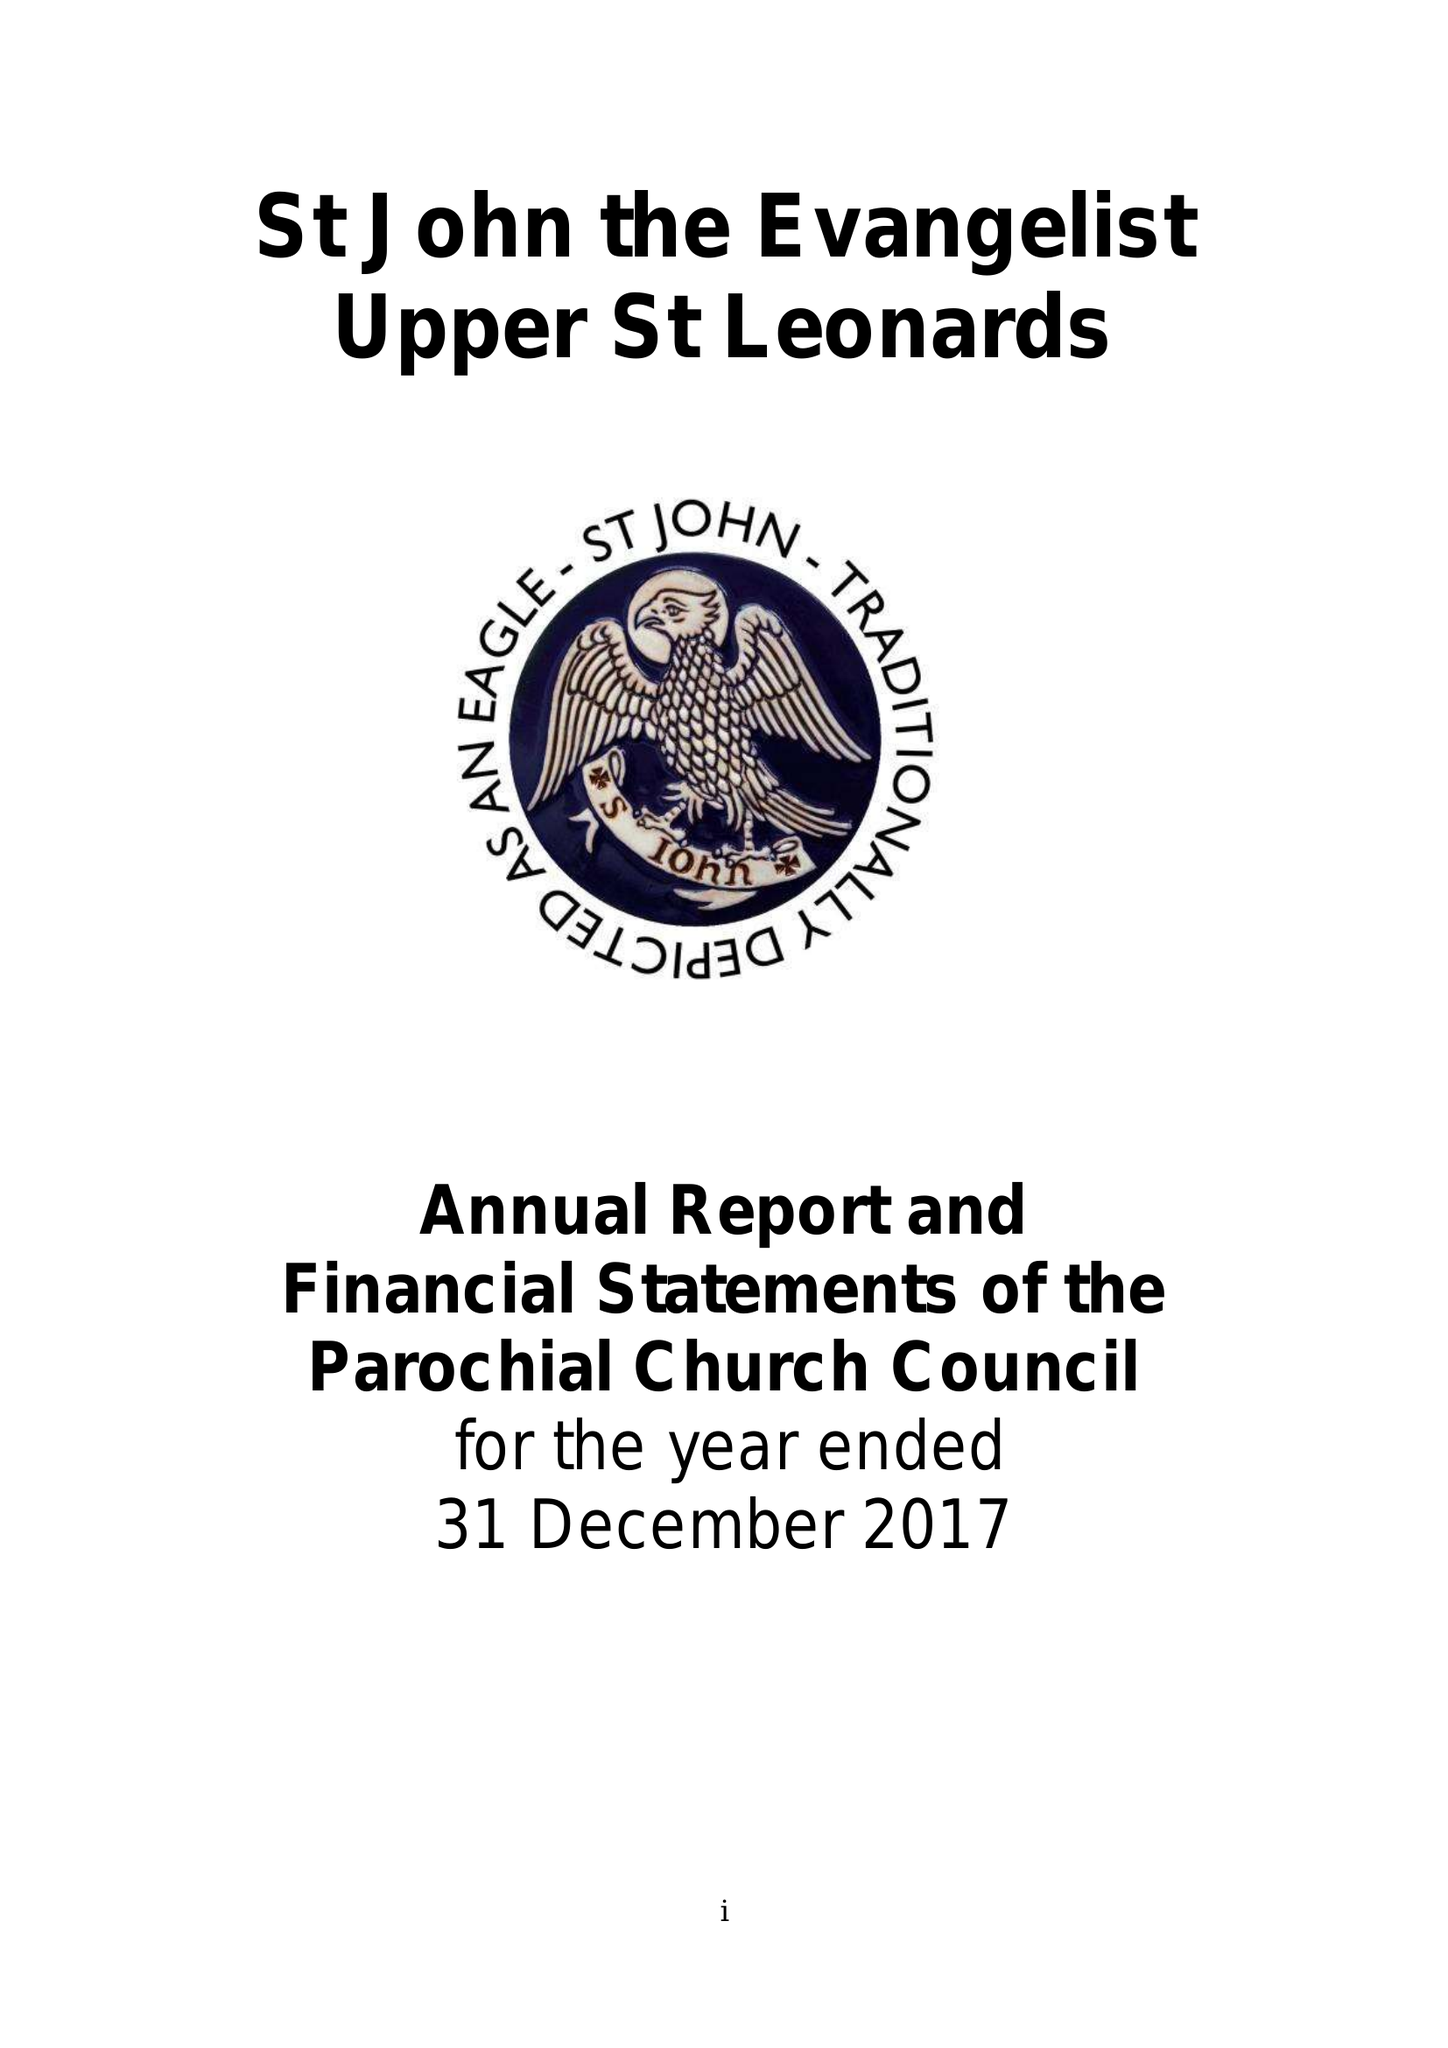What is the value for the address__postcode?
Answer the question using a single word or phrase. TN38 0LF 